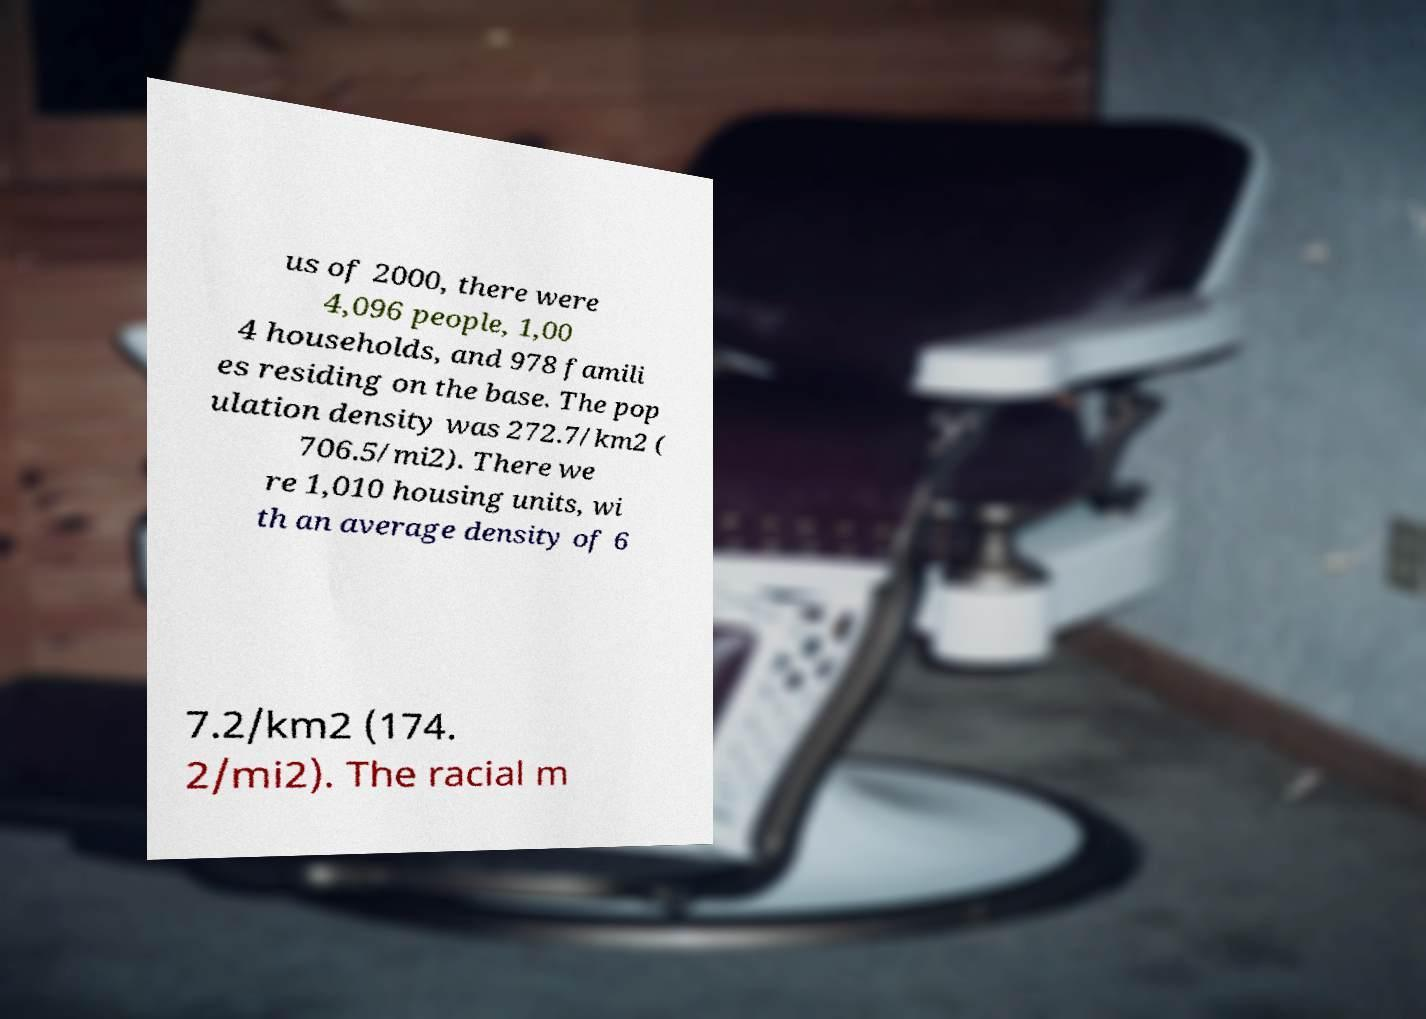For documentation purposes, I need the text within this image transcribed. Could you provide that? us of 2000, there were 4,096 people, 1,00 4 households, and 978 famili es residing on the base. The pop ulation density was 272.7/km2 ( 706.5/mi2). There we re 1,010 housing units, wi th an average density of 6 7.2/km2 (174. 2/mi2). The racial m 